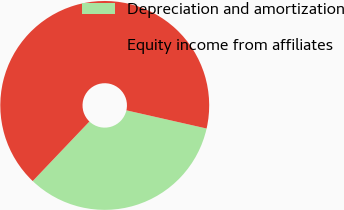Convert chart. <chart><loc_0><loc_0><loc_500><loc_500><pie_chart><fcel>Depreciation and amortization<fcel>Equity income from affiliates<nl><fcel>33.56%<fcel>66.44%<nl></chart> 